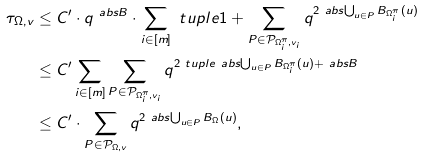<formula> <loc_0><loc_0><loc_500><loc_500>\tau _ { \Omega , v } & \leq C ^ { \prime } \cdot q ^ { \ a b s { B } } \cdot \sum _ { i \in [ m ] } \ t u p l e { 1 + \sum _ { P \in \mathcal { P } _ { \Omega _ { i } ^ { \pi } , v _ { i } } } q ^ { 2 \ a b s { \bigcup _ { u \in P } B _ { \Omega _ { i } ^ { \pi } } ( u ) } } } \\ & \leq C ^ { \prime } \sum _ { i \in [ m ] } \sum _ { P \in \mathcal { P } _ { \Omega _ { i } ^ { \pi } , v _ { i } } } q ^ { 2 \ t u p l e { \ a b s { \bigcup _ { u \in P } B _ { \Omega _ { i } ^ { \pi } } ( u ) } + \ a b s { B } } } \\ & \leq C ^ { \prime } \cdot \sum _ { P \in \mathcal { P } _ { \Omega , v } } q ^ { 2 \ a b s { \bigcup _ { u \in P } B _ { \Omega } ( u ) } } ,</formula> 